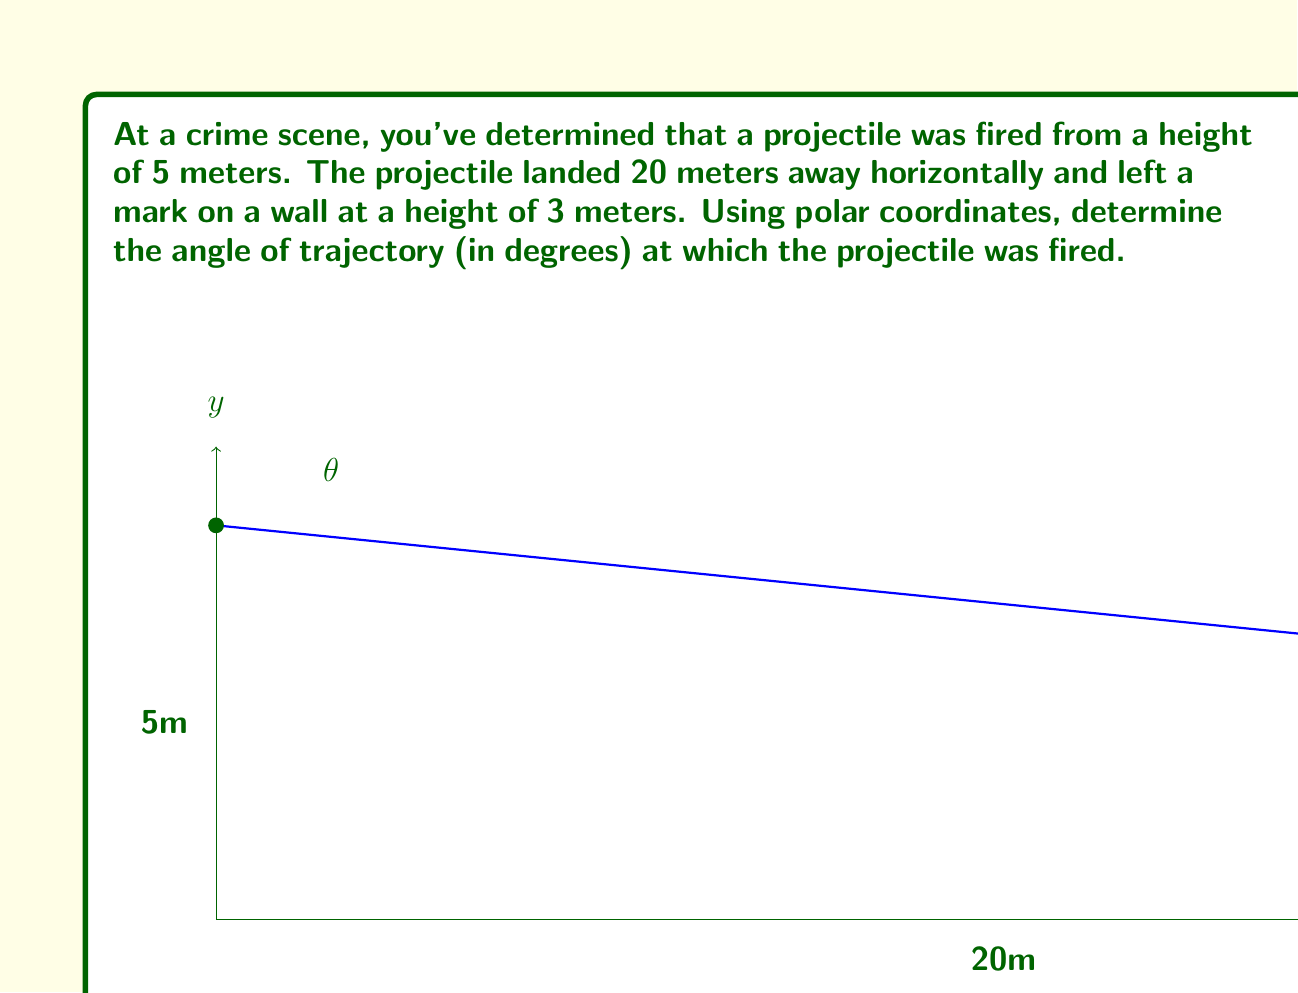Teach me how to tackle this problem. To solve this problem, we'll follow these steps:

1) First, let's identify our polar coordinates. The origin will be at the firing point, and we'll consider the positive x-axis as our reference line ($\theta = 0$).

2) We need to find the polar coordinates $(r, \theta)$ of the landing point. We know:
   - Horizontal distance: 20 m
   - Vertical distance: 5 m - 3 m = 2 m (drop in height)

3) To find $r$, we use the Pythagorean theorem:

   $$r = \sqrt{20^2 + 2^2} = \sqrt{404} = 20.1 \text{ m}$$

4) To find $\theta$, we use the arctangent function:

   $$\theta = \arctan(\frac{2}{20}) = \arctan(0.1)$$

5) However, this gives us the angle below the horizontal. We need the angle above the horizontal, so we subtract this from 90°:

   $$\text{Angle of trajectory} = 90° - \arctan(0.1)$$

6) Calculate the final result:
   
   $$90° - \arctan(0.1) = 90° - 5.71° = 84.29°$$

7) Round to two decimal places: 84.29°
Answer: The angle of trajectory is approximately 84.29°. 